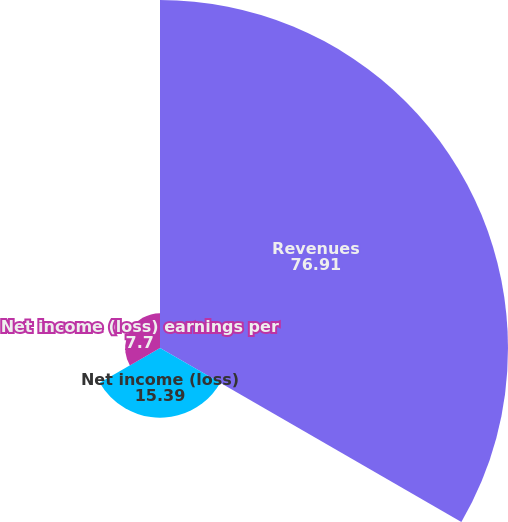Convert chart to OTSL. <chart><loc_0><loc_0><loc_500><loc_500><pie_chart><fcel>Revenues<fcel>Net income (loss)<fcel>Net income (loss) earnings per<nl><fcel>76.91%<fcel>15.39%<fcel>7.7%<nl></chart> 